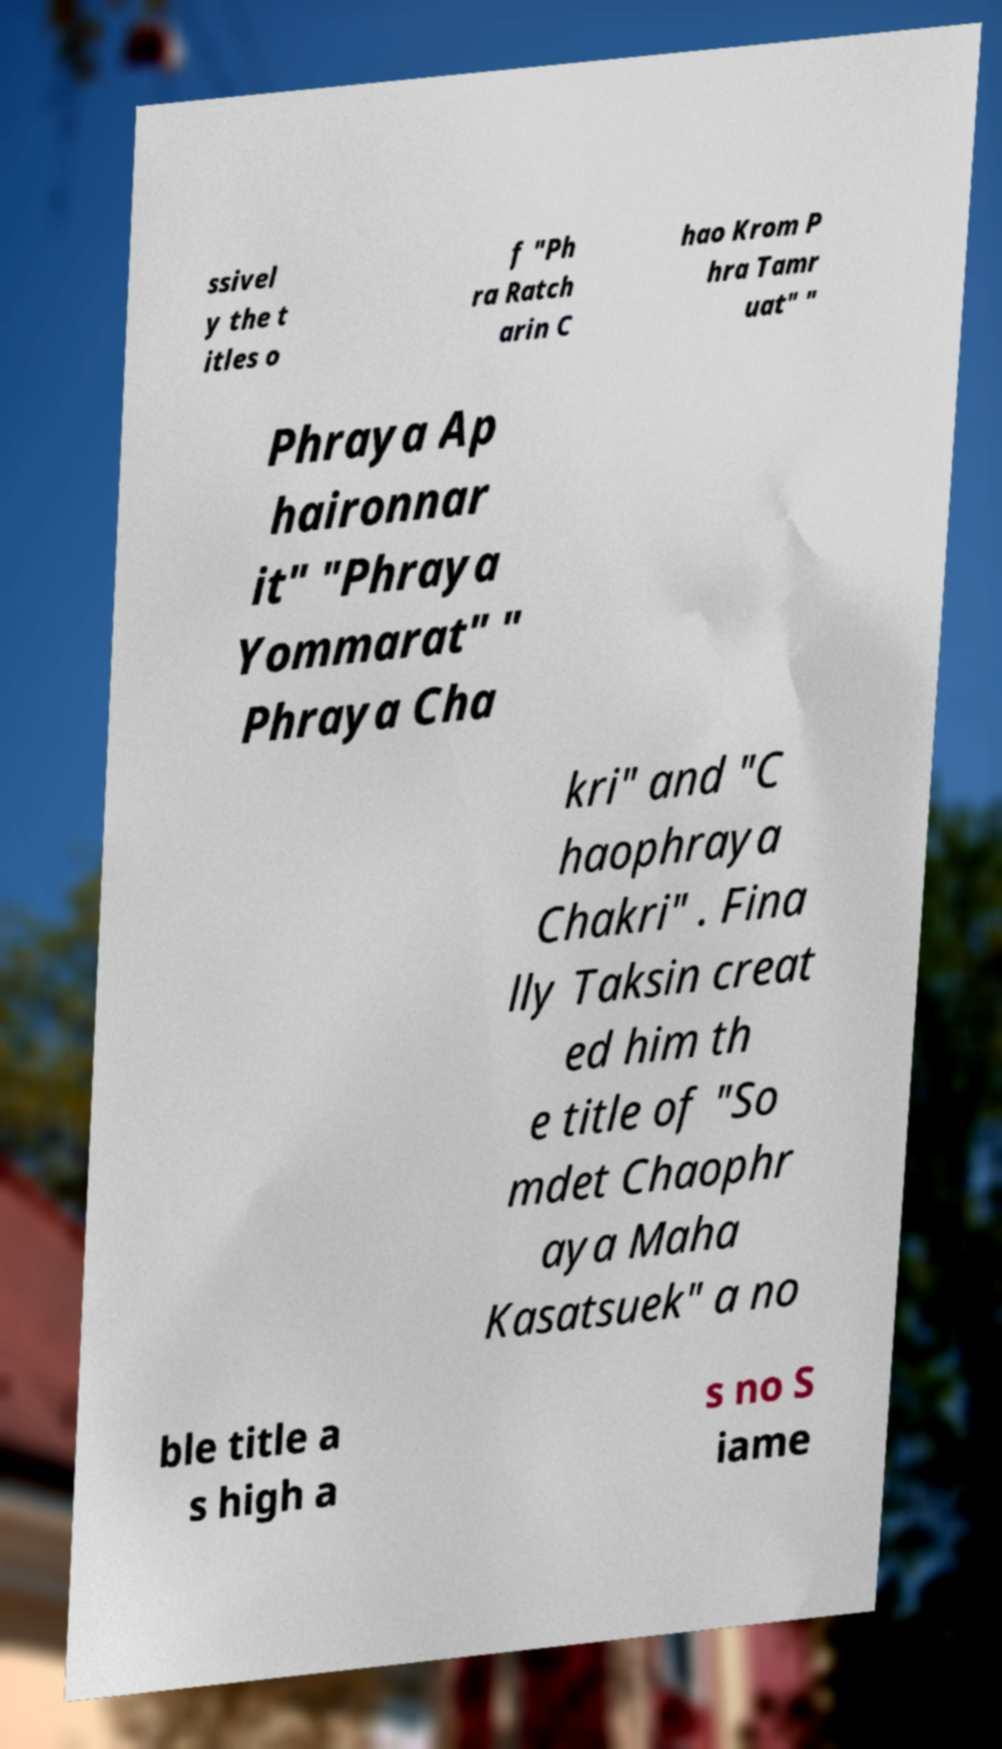Could you extract and type out the text from this image? ssivel y the t itles o f "Ph ra Ratch arin C hao Krom P hra Tamr uat" " Phraya Ap haironnar it" "Phraya Yommarat" " Phraya Cha kri" and "C haophraya Chakri" . Fina lly Taksin creat ed him th e title of "So mdet Chaophr aya Maha Kasatsuek" a no ble title a s high a s no S iame 